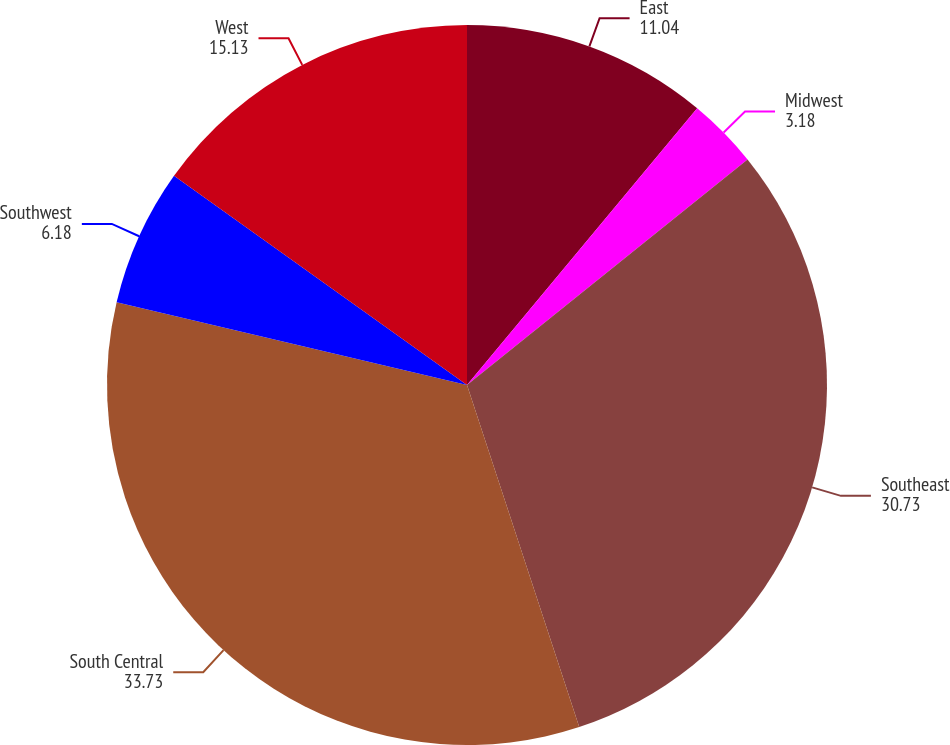Convert chart. <chart><loc_0><loc_0><loc_500><loc_500><pie_chart><fcel>East<fcel>Midwest<fcel>Southeast<fcel>South Central<fcel>Southwest<fcel>West<nl><fcel>11.04%<fcel>3.18%<fcel>30.73%<fcel>33.73%<fcel>6.18%<fcel>15.13%<nl></chart> 